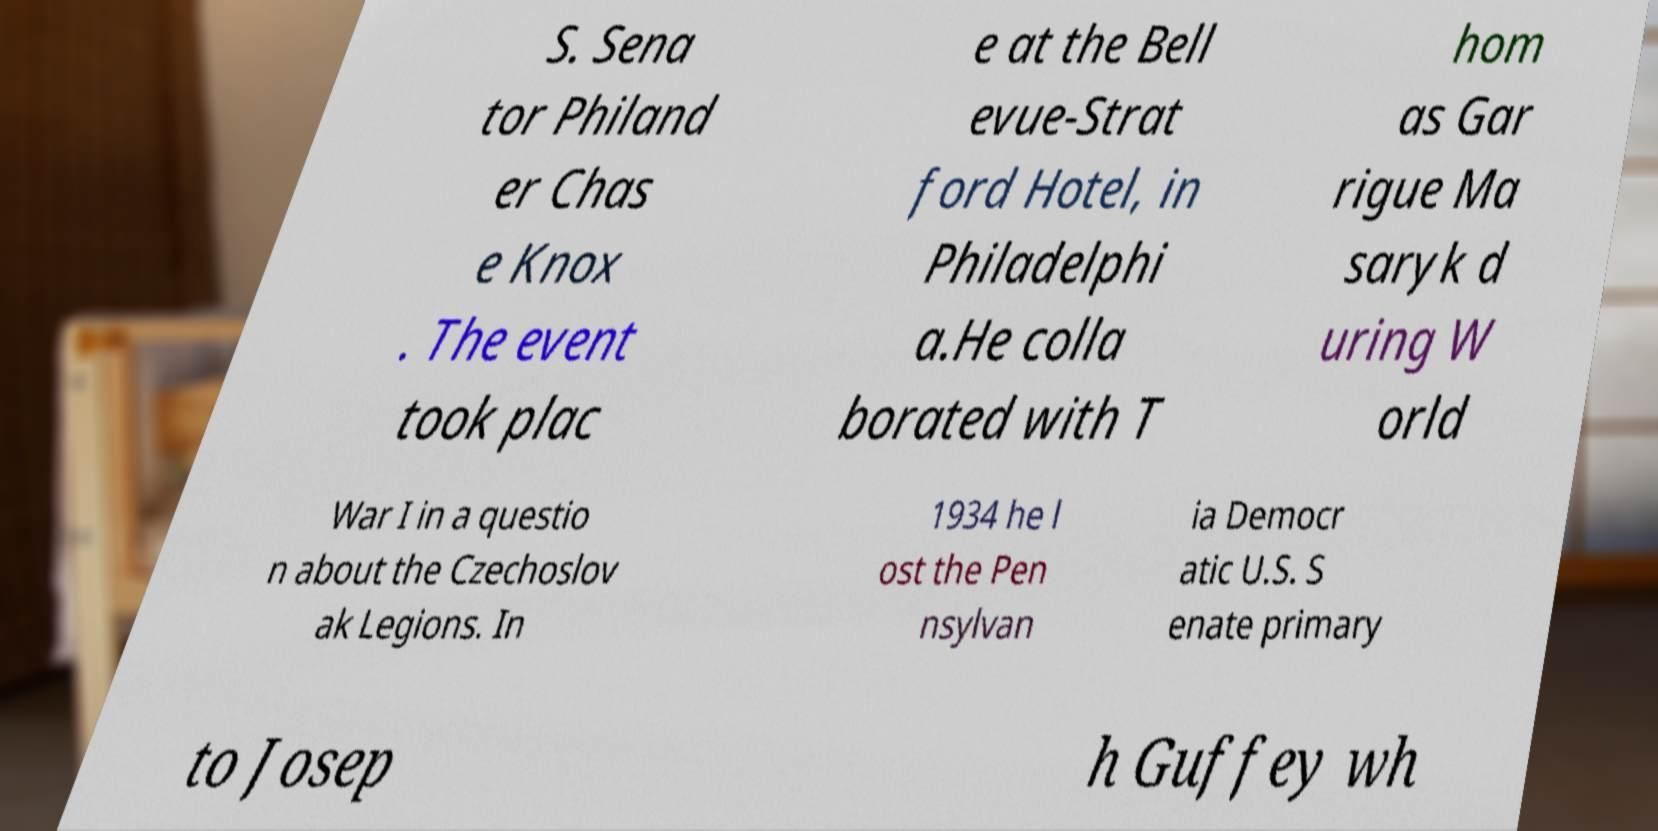Please read and relay the text visible in this image. What does it say? S. Sena tor Philand er Chas e Knox . The event took plac e at the Bell evue-Strat ford Hotel, in Philadelphi a.He colla borated with T hom as Gar rigue Ma saryk d uring W orld War I in a questio n about the Czechoslov ak Legions. In 1934 he l ost the Pen nsylvan ia Democr atic U.S. S enate primary to Josep h Guffey wh 